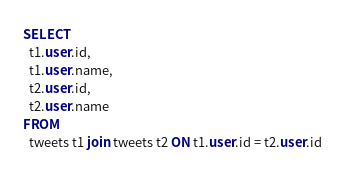<code> <loc_0><loc_0><loc_500><loc_500><_SQL_>SELECT
  t1.user.id,
  t1.user.name,
  t2.user.id,
  t2.user.name
FROM
  tweets t1 join tweets t2 ON t1.user.id = t2.user.id</code> 